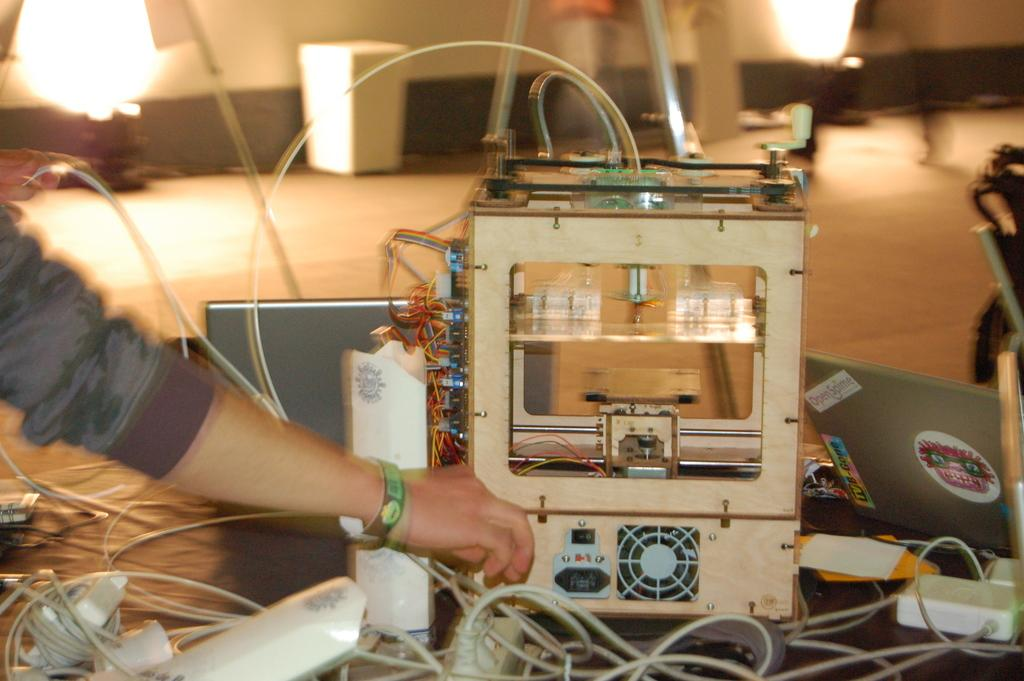What part of a person can be seen in the image? There is a person's hand in the image. What type of objects are present in the image? Cables, a connector box, electronic devices, and stickers are visible in the image. What can be seen in the background of the image? There are lights and other objects in the background of the image. What type of payment is accepted at the attraction in the image? There is no attraction present in the image, so no payment can be accepted. What is the floor made of in the image? The image does not show the floor, so it cannot be determined what it is made of. 